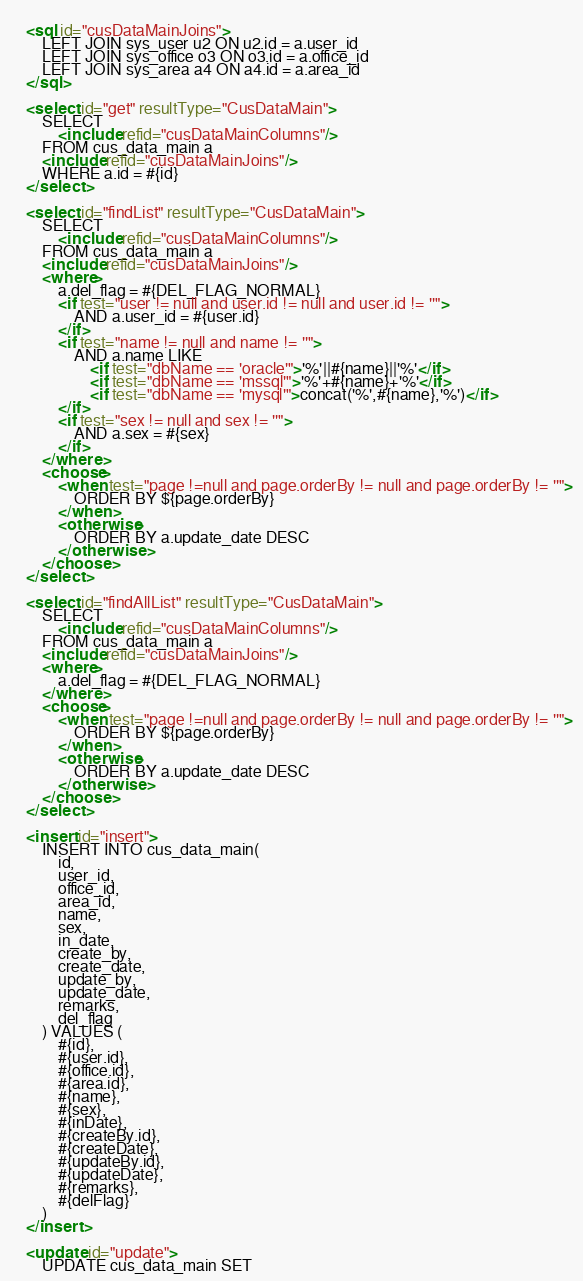<code> <loc_0><loc_0><loc_500><loc_500><_XML_>	
	<sql id="cusDataMainJoins">
		LEFT JOIN sys_user u2 ON u2.id = a.user_id
		LEFT JOIN sys_office o3 ON o3.id = a.office_id
		LEFT JOIN sys_area a4 ON a4.id = a.area_id
	</sql>
    
	<select id="get" resultType="CusDataMain">
		SELECT 
			<include refid="cusDataMainColumns"/>
		FROM cus_data_main a
		<include refid="cusDataMainJoins"/>
		WHERE a.id = #{id}
	</select>
	
	<select id="findList" resultType="CusDataMain">
		SELECT 
			<include refid="cusDataMainColumns"/>
		FROM cus_data_main a
		<include refid="cusDataMainJoins"/>
		<where>
			a.del_flag = #{DEL_FLAG_NORMAL}
			<if test="user != null and user.id != null and user.id != ''">
				AND a.user_id = #{user.id}
			</if>
			<if test="name != null and name != ''">
				AND a.name LIKE 
					<if test="dbName == 'oracle'">'%'||#{name}||'%'</if>
					<if test="dbName == 'mssql'">'%'+#{name}+'%'</if>
					<if test="dbName == 'mysql'">concat('%',#{name},'%')</if>
			</if>
			<if test="sex != null and sex != ''">
				AND a.sex = #{sex}
			</if>
		</where>
		<choose>
			<when test="page !=null and page.orderBy != null and page.orderBy != ''">
				ORDER BY ${page.orderBy}
			</when>
			<otherwise>
				ORDER BY a.update_date DESC
			</otherwise>
		</choose>
	</select>
	
	<select id="findAllList" resultType="CusDataMain">
		SELECT 
			<include refid="cusDataMainColumns"/>
		FROM cus_data_main a
		<include refid="cusDataMainJoins"/>
		<where>
			a.del_flag = #{DEL_FLAG_NORMAL}
		</where>		
		<choose>
			<when test="page !=null and page.orderBy != null and page.orderBy != ''">
				ORDER BY ${page.orderBy}
			</when>
			<otherwise>
				ORDER BY a.update_date DESC
			</otherwise>
		</choose>
	</select>
	
	<insert id="insert">
		INSERT INTO cus_data_main(
			id,
			user_id,
			office_id,
			area_id,
			name,
			sex,
			in_date,
			create_by,
			create_date,
			update_by,
			update_date,
			remarks,
			del_flag
		) VALUES (
			#{id},
			#{user.id},
			#{office.id},
			#{area.id},
			#{name},
			#{sex},
			#{inDate},
			#{createBy.id},
			#{createDate},
			#{updateBy.id},
			#{updateDate},
			#{remarks},
			#{delFlag}
		)
	</insert>
	
	<update id="update">
		UPDATE cus_data_main SET 	</code> 